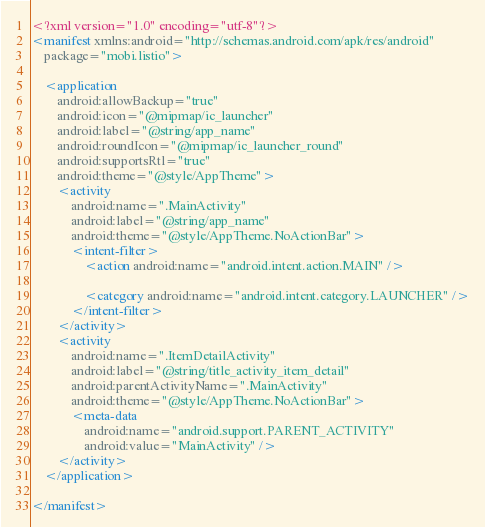<code> <loc_0><loc_0><loc_500><loc_500><_XML_><?xml version="1.0" encoding="utf-8"?>
<manifest xmlns:android="http://schemas.android.com/apk/res/android"
    package="mobi.listio">

    <application
        android:allowBackup="true"
        android:icon="@mipmap/ic_launcher"
        android:label="@string/app_name"
        android:roundIcon="@mipmap/ic_launcher_round"
        android:supportsRtl="true"
        android:theme="@style/AppTheme">
        <activity
            android:name=".MainActivity"
            android:label="@string/app_name"
            android:theme="@style/AppTheme.NoActionBar">
            <intent-filter>
                <action android:name="android.intent.action.MAIN" />

                <category android:name="android.intent.category.LAUNCHER" />
            </intent-filter>
        </activity>
        <activity
            android:name=".ItemDetailActivity"
            android:label="@string/title_activity_item_detail"
            android:parentActivityName=".MainActivity"
            android:theme="@style/AppTheme.NoActionBar">
            <meta-data
                android:name="android.support.PARENT_ACTIVITY"
                android:value="MainActivity" />
        </activity>
    </application>

</manifest></code> 